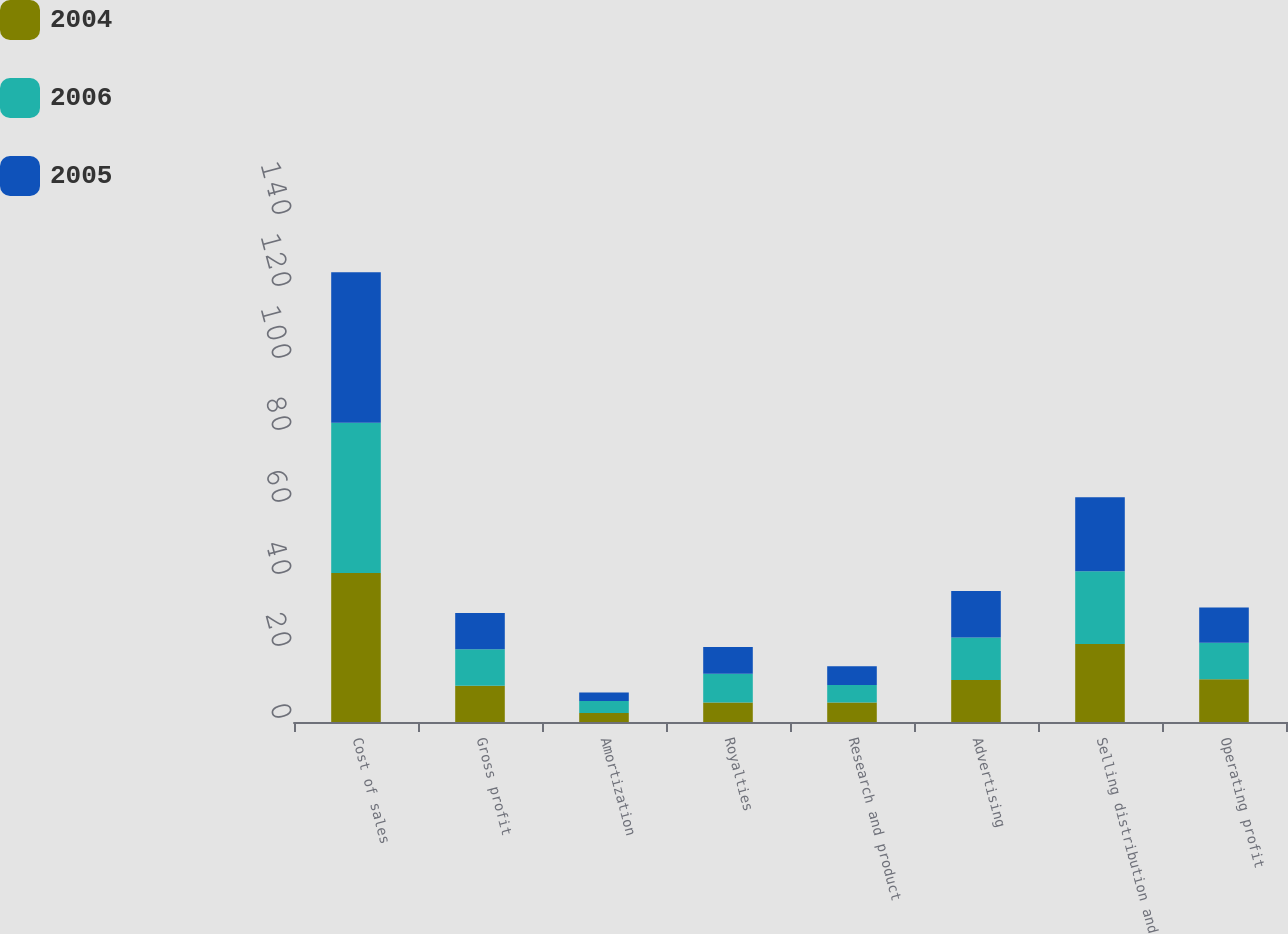<chart> <loc_0><loc_0><loc_500><loc_500><stacked_bar_chart><ecel><fcel>Cost of sales<fcel>Gross profit<fcel>Amortization<fcel>Royalties<fcel>Research and product<fcel>Advertising<fcel>Selling distribution and<fcel>Operating profit<nl><fcel>2004<fcel>41.4<fcel>10.1<fcel>2.5<fcel>5.4<fcel>5.4<fcel>11.7<fcel>21.7<fcel>11.9<nl><fcel>2006<fcel>41.7<fcel>10.1<fcel>3.3<fcel>8<fcel>4.9<fcel>11.8<fcel>20.2<fcel>10.1<nl><fcel>2005<fcel>41.8<fcel>10.1<fcel>2.4<fcel>7.4<fcel>5.2<fcel>12.9<fcel>20.5<fcel>9.8<nl></chart> 